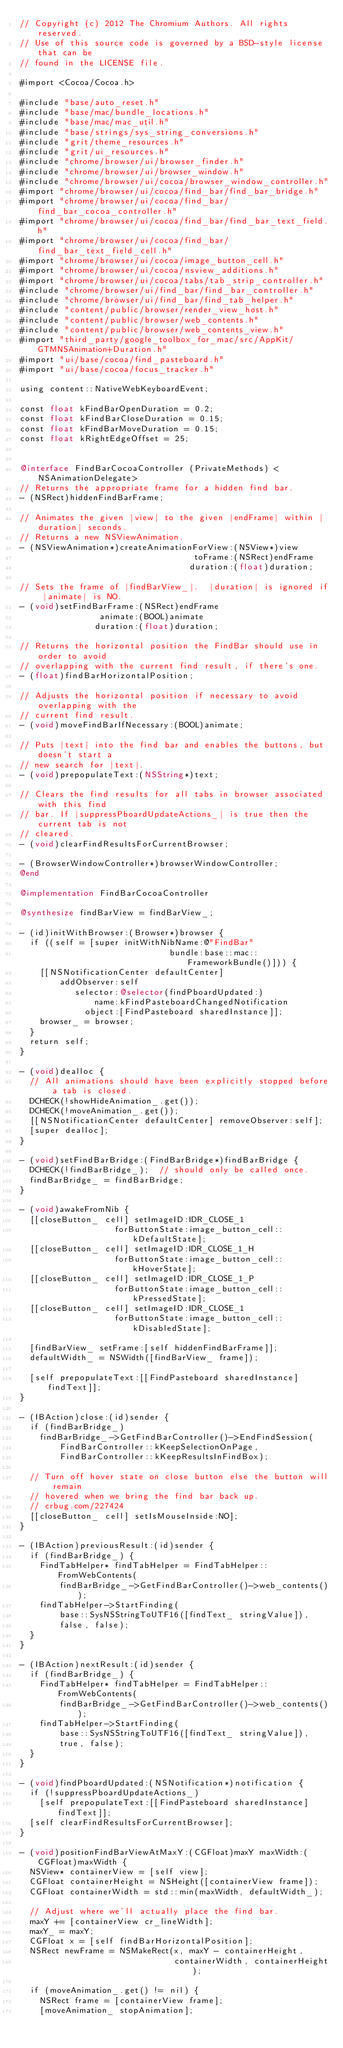Convert code to text. <code><loc_0><loc_0><loc_500><loc_500><_ObjectiveC_>// Copyright (c) 2012 The Chromium Authors. All rights reserved.
// Use of this source code is governed by a BSD-style license that can be
// found in the LICENSE file.

#import <Cocoa/Cocoa.h>

#include "base/auto_reset.h"
#include "base/mac/bundle_locations.h"
#include "base/mac/mac_util.h"
#include "base/strings/sys_string_conversions.h"
#include "grit/theme_resources.h"
#include "grit/ui_resources.h"
#include "chrome/browser/ui/browser_finder.h"
#include "chrome/browser/ui/browser_window.h"
#include "chrome/browser/ui/cocoa/browser_window_controller.h"
#import "chrome/browser/ui/cocoa/find_bar/find_bar_bridge.h"
#import "chrome/browser/ui/cocoa/find_bar/find_bar_cocoa_controller.h"
#import "chrome/browser/ui/cocoa/find_bar/find_bar_text_field.h"
#import "chrome/browser/ui/cocoa/find_bar/find_bar_text_field_cell.h"
#import "chrome/browser/ui/cocoa/image_button_cell.h"
#import "chrome/browser/ui/cocoa/nsview_additions.h"
#import "chrome/browser/ui/cocoa/tabs/tab_strip_controller.h"
#include "chrome/browser/ui/find_bar/find_bar_controller.h"
#include "chrome/browser/ui/find_bar/find_tab_helper.h"
#include "content/public/browser/render_view_host.h"
#include "content/public/browser/web_contents.h"
#include "content/public/browser/web_contents_view.h"
#import "third_party/google_toolbox_for_mac/src/AppKit/GTMNSAnimation+Duration.h"
#import "ui/base/cocoa/find_pasteboard.h"
#import "ui/base/cocoa/focus_tracker.h"

using content::NativeWebKeyboardEvent;

const float kFindBarOpenDuration = 0.2;
const float kFindBarCloseDuration = 0.15;
const float kFindBarMoveDuration = 0.15;
const float kRightEdgeOffset = 25;


@interface FindBarCocoaController (PrivateMethods) <NSAnimationDelegate>
// Returns the appropriate frame for a hidden find bar.
- (NSRect)hiddenFindBarFrame;

// Animates the given |view| to the given |endFrame| within |duration| seconds.
// Returns a new NSViewAnimation.
- (NSViewAnimation*)createAnimationForView:(NSView*)view
                                   toFrame:(NSRect)endFrame
                                  duration:(float)duration;

// Sets the frame of |findBarView_|.  |duration| is ignored if |animate| is NO.
- (void)setFindBarFrame:(NSRect)endFrame
                animate:(BOOL)animate
               duration:(float)duration;

// Returns the horizontal position the FindBar should use in order to avoid
// overlapping with the current find result, if there's one.
- (float)findBarHorizontalPosition;

// Adjusts the horizontal position if necessary to avoid overlapping with the
// current find result.
- (void)moveFindBarIfNecessary:(BOOL)animate;

// Puts |text| into the find bar and enables the buttons, but doesn't start a
// new search for |text|.
- (void)prepopulateText:(NSString*)text;

// Clears the find results for all tabs in browser associated with this find
// bar. If |suppressPboardUpdateActions_| is true then the current tab is not
// cleared.
- (void)clearFindResultsForCurrentBrowser;

- (BrowserWindowController*)browserWindowController;
@end

@implementation FindBarCocoaController

@synthesize findBarView = findBarView_;

- (id)initWithBrowser:(Browser*)browser {
  if ((self = [super initWithNibName:@"FindBar"
                              bundle:base::mac::FrameworkBundle()])) {
    [[NSNotificationCenter defaultCenter]
        addObserver:self
           selector:@selector(findPboardUpdated:)
               name:kFindPasteboardChangedNotification
             object:[FindPasteboard sharedInstance]];
    browser_ = browser;
  }
  return self;
}

- (void)dealloc {
  // All animations should have been explicitly stopped before a tab is closed.
  DCHECK(!showHideAnimation_.get());
  DCHECK(!moveAnimation_.get());
  [[NSNotificationCenter defaultCenter] removeObserver:self];
  [super dealloc];
}

- (void)setFindBarBridge:(FindBarBridge*)findBarBridge {
  DCHECK(!findBarBridge_);  // should only be called once.
  findBarBridge_ = findBarBridge;
}

- (void)awakeFromNib {
  [[closeButton_ cell] setImageID:IDR_CLOSE_1
                   forButtonState:image_button_cell::kDefaultState];
  [[closeButton_ cell] setImageID:IDR_CLOSE_1_H
                   forButtonState:image_button_cell::kHoverState];
  [[closeButton_ cell] setImageID:IDR_CLOSE_1_P
                   forButtonState:image_button_cell::kPressedState];
  [[closeButton_ cell] setImageID:IDR_CLOSE_1
                   forButtonState:image_button_cell::kDisabledState];

  [findBarView_ setFrame:[self hiddenFindBarFrame]];
  defaultWidth_ = NSWidth([findBarView_ frame]);

  [self prepopulateText:[[FindPasteboard sharedInstance] findText]];
}

- (IBAction)close:(id)sender {
  if (findBarBridge_)
    findBarBridge_->GetFindBarController()->EndFindSession(
        FindBarController::kKeepSelectionOnPage,
        FindBarController::kKeepResultsInFindBox);

  // Turn off hover state on close button else the button will remain
  // hovered when we bring the find bar back up.
  // crbug.com/227424
  [[closeButton_ cell] setIsMouseInside:NO];
}

- (IBAction)previousResult:(id)sender {
  if (findBarBridge_) {
    FindTabHelper* findTabHelper = FindTabHelper::FromWebContents(
        findBarBridge_->GetFindBarController()->web_contents());
    findTabHelper->StartFinding(
        base::SysNSStringToUTF16([findText_ stringValue]),
        false, false);
  }
}

- (IBAction)nextResult:(id)sender {
  if (findBarBridge_) {
    FindTabHelper* findTabHelper = FindTabHelper::FromWebContents(
        findBarBridge_->GetFindBarController()->web_contents());
    findTabHelper->StartFinding(
        base::SysNSStringToUTF16([findText_ stringValue]),
        true, false);
  }
}

- (void)findPboardUpdated:(NSNotification*)notification {
  if (!suppressPboardUpdateActions_)
    [self prepopulateText:[[FindPasteboard sharedInstance] findText]];
  [self clearFindResultsForCurrentBrowser];
}

- (void)positionFindBarViewAtMaxY:(CGFloat)maxY maxWidth:(CGFloat)maxWidth {
  NSView* containerView = [self view];
  CGFloat containerHeight = NSHeight([containerView frame]);
  CGFloat containerWidth = std::min(maxWidth, defaultWidth_);

  // Adjust where we'll actually place the find bar.
  maxY += [containerView cr_lineWidth];
  maxY_ = maxY;
  CGFloat x = [self findBarHorizontalPosition];
  NSRect newFrame = NSMakeRect(x, maxY - containerHeight,
                               containerWidth, containerHeight);

  if (moveAnimation_.get() != nil) {
    NSRect frame = [containerView frame];
    [moveAnimation_ stopAnimation];</code> 